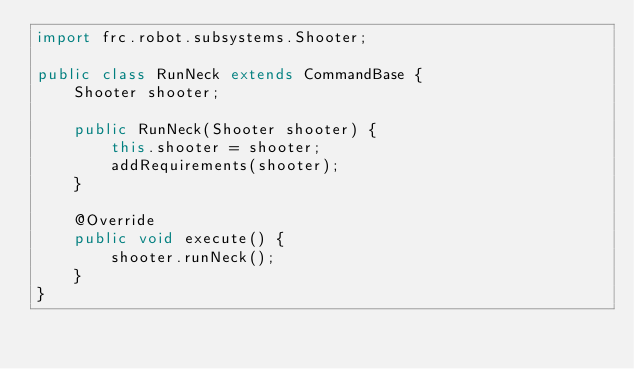<code> <loc_0><loc_0><loc_500><loc_500><_Java_>import frc.robot.subsystems.Shooter;

public class RunNeck extends CommandBase {
    Shooter shooter;

    public RunNeck(Shooter shooter) {
        this.shooter = shooter;
        addRequirements(shooter);
    }

    @Override
    public void execute() {
        shooter.runNeck();
    }
}
</code> 